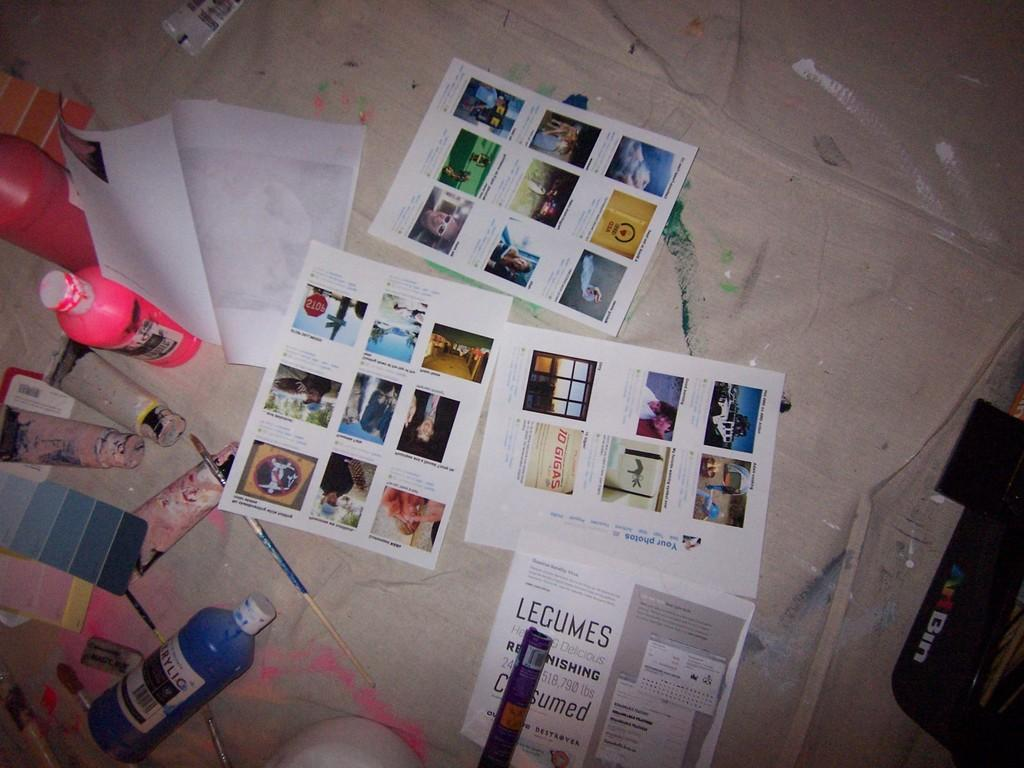<image>
Render a clear and concise summary of the photo. Paints and pictures from Legumes laying on the floor 